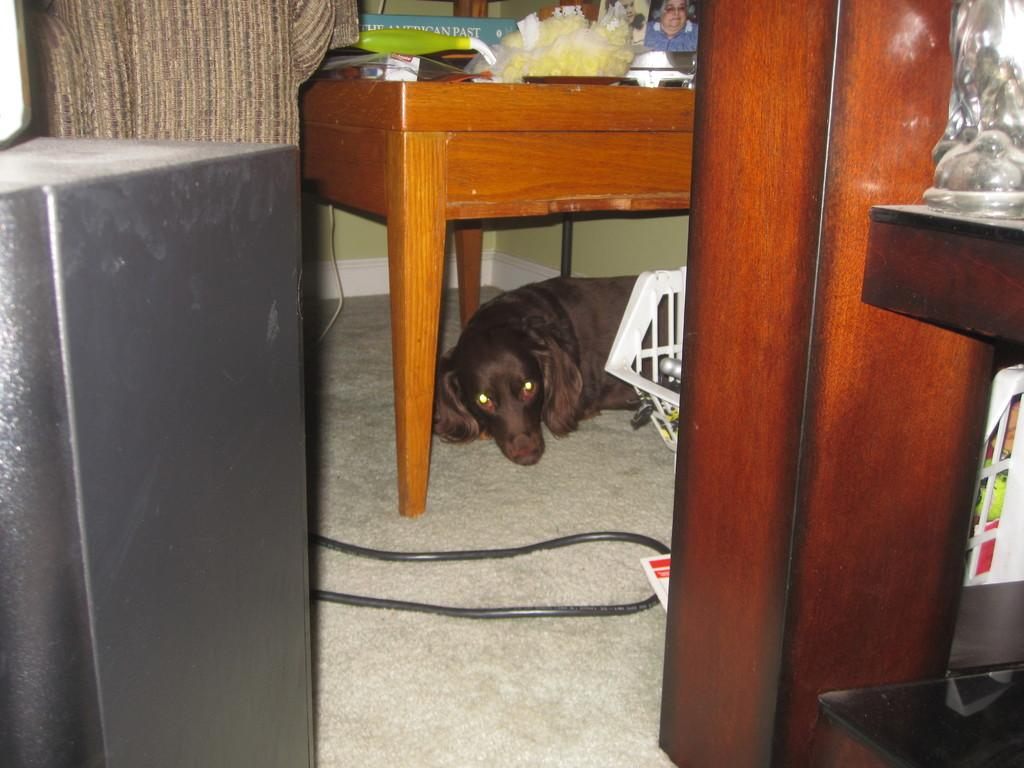What type of animal is present in the image? There is a dog in the image. What is the dog doing in the image? The dog is sleeping. Where is the dog located in the image? The dog is under a wooden table. What type of page can be seen in the image? There is no page present in the image; it features a dog sleeping under a wooden table. What type of rice is being cooked in the image? There is no rice being cooked in the image. 